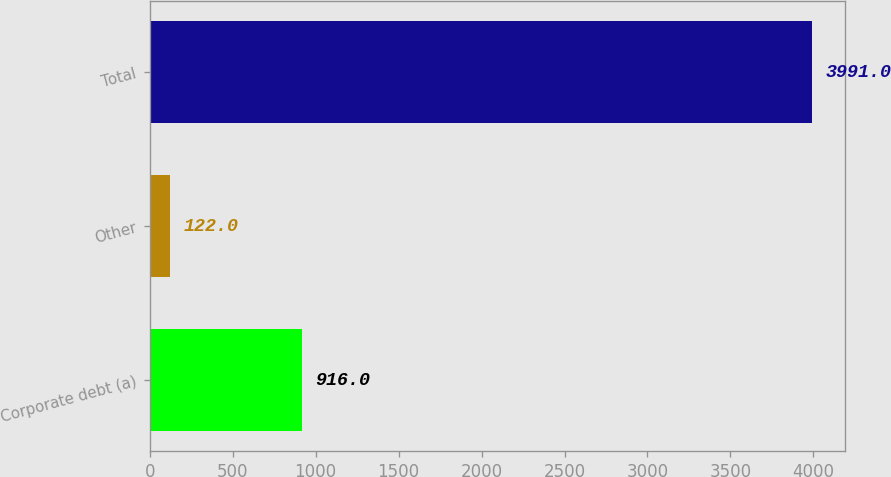<chart> <loc_0><loc_0><loc_500><loc_500><bar_chart><fcel>Corporate debt (a)<fcel>Other<fcel>Total<nl><fcel>916<fcel>122<fcel>3991<nl></chart> 